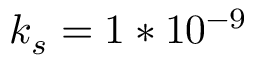<formula> <loc_0><loc_0><loc_500><loc_500>k _ { s } = 1 * 1 0 ^ { - 9 }</formula> 